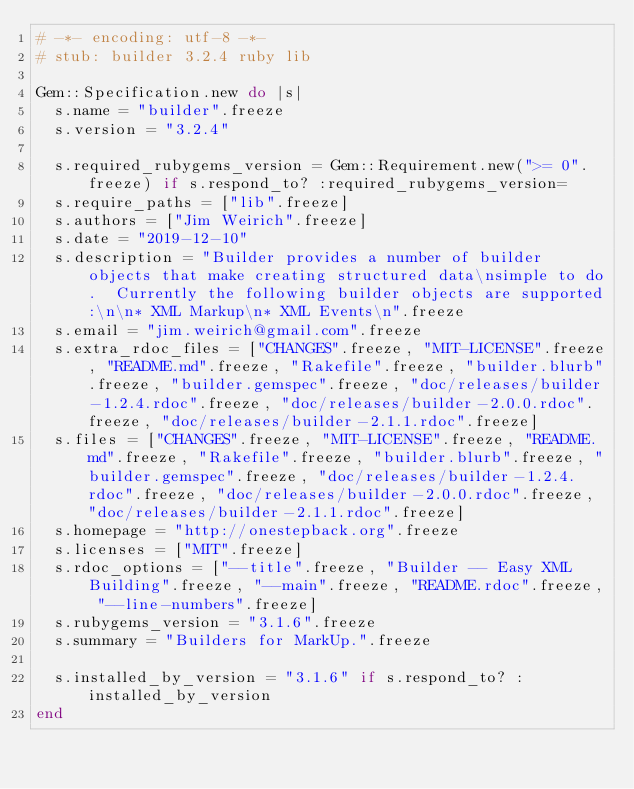<code> <loc_0><loc_0><loc_500><loc_500><_Ruby_># -*- encoding: utf-8 -*-
# stub: builder 3.2.4 ruby lib

Gem::Specification.new do |s|
  s.name = "builder".freeze
  s.version = "3.2.4"

  s.required_rubygems_version = Gem::Requirement.new(">= 0".freeze) if s.respond_to? :required_rubygems_version=
  s.require_paths = ["lib".freeze]
  s.authors = ["Jim Weirich".freeze]
  s.date = "2019-12-10"
  s.description = "Builder provides a number of builder objects that make creating structured data\nsimple to do.  Currently the following builder objects are supported:\n\n* XML Markup\n* XML Events\n".freeze
  s.email = "jim.weirich@gmail.com".freeze
  s.extra_rdoc_files = ["CHANGES".freeze, "MIT-LICENSE".freeze, "README.md".freeze, "Rakefile".freeze, "builder.blurb".freeze, "builder.gemspec".freeze, "doc/releases/builder-1.2.4.rdoc".freeze, "doc/releases/builder-2.0.0.rdoc".freeze, "doc/releases/builder-2.1.1.rdoc".freeze]
  s.files = ["CHANGES".freeze, "MIT-LICENSE".freeze, "README.md".freeze, "Rakefile".freeze, "builder.blurb".freeze, "builder.gemspec".freeze, "doc/releases/builder-1.2.4.rdoc".freeze, "doc/releases/builder-2.0.0.rdoc".freeze, "doc/releases/builder-2.1.1.rdoc".freeze]
  s.homepage = "http://onestepback.org".freeze
  s.licenses = ["MIT".freeze]
  s.rdoc_options = ["--title".freeze, "Builder -- Easy XML Building".freeze, "--main".freeze, "README.rdoc".freeze, "--line-numbers".freeze]
  s.rubygems_version = "3.1.6".freeze
  s.summary = "Builders for MarkUp.".freeze

  s.installed_by_version = "3.1.6" if s.respond_to? :installed_by_version
end
</code> 